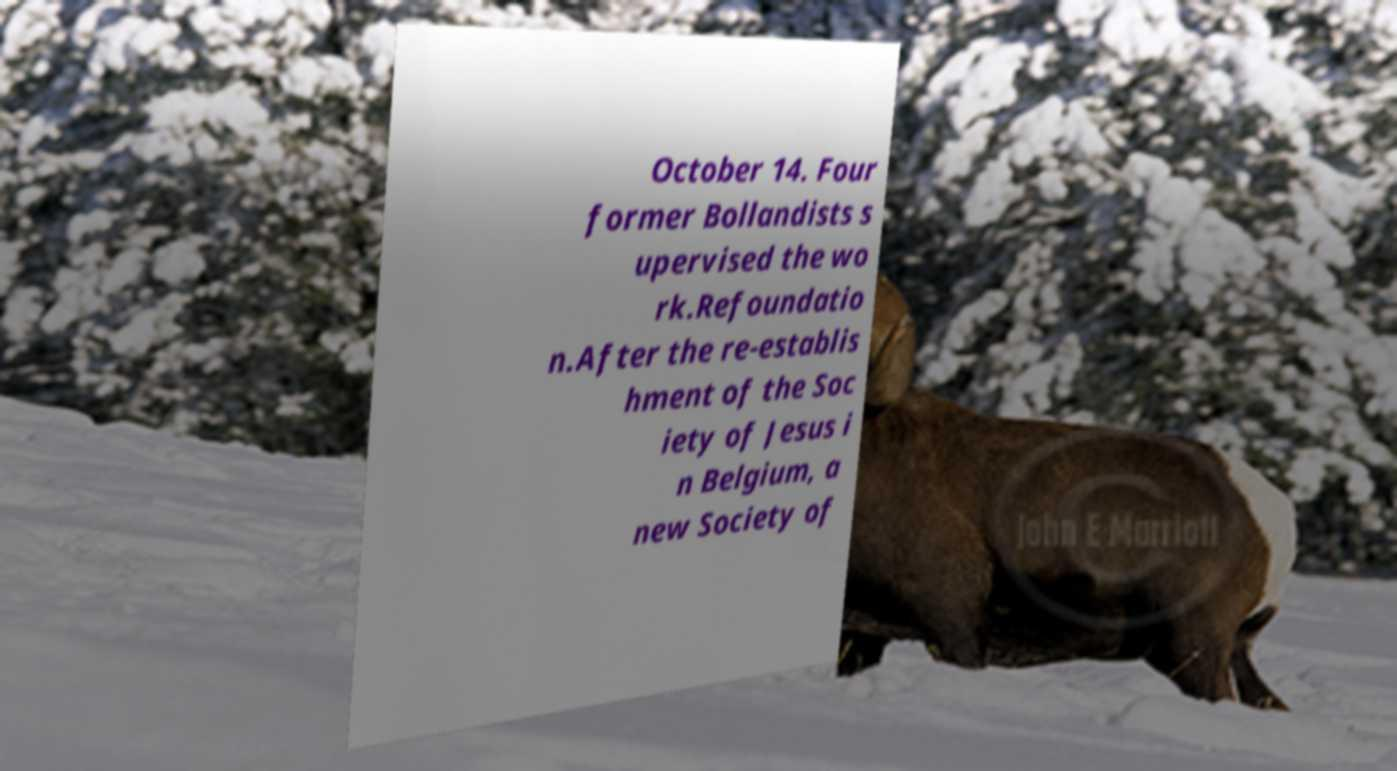What messages or text are displayed in this image? I need them in a readable, typed format. October 14. Four former Bollandists s upervised the wo rk.Refoundatio n.After the re-establis hment of the Soc iety of Jesus i n Belgium, a new Society of 